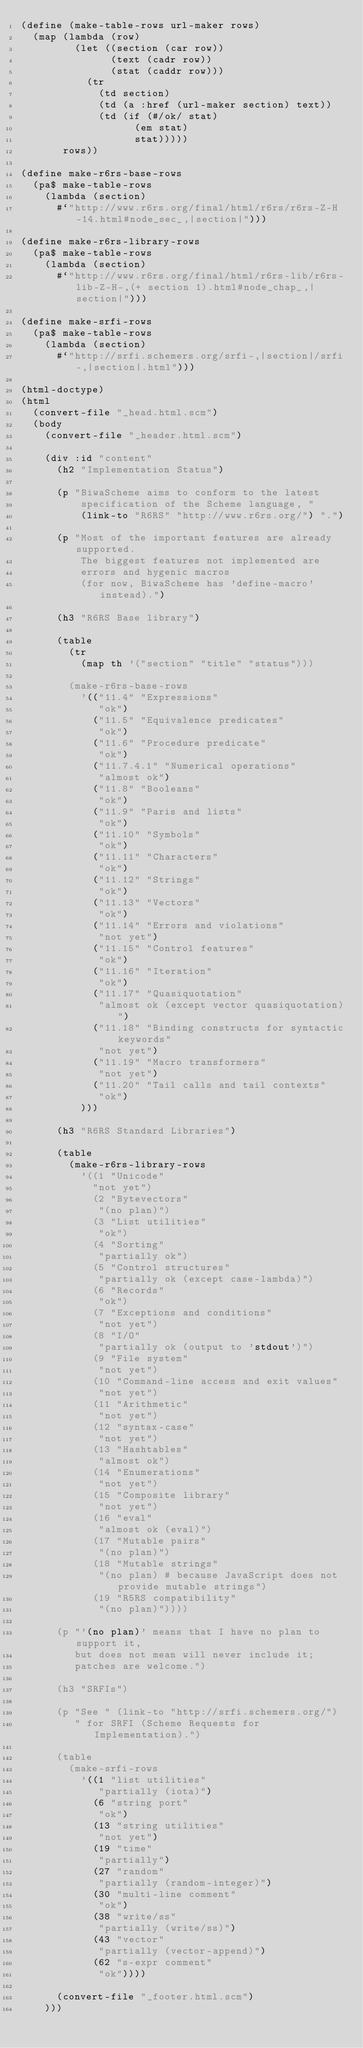Convert code to text. <code><loc_0><loc_0><loc_500><loc_500><_Scheme_>(define (make-table-rows url-maker rows)
  (map (lambda (row)
         (let ((section (car row))
               (text (cadr row))
               (stat (caddr row)))
           (tr
             (td section)
             (td (a :href (url-maker section) text))
             (td (if (#/ok/ stat)
                   (em stat)
                   stat)))))
       rows))

(define make-r6rs-base-rows 
  (pa$ make-table-rows
    (lambda (section)
      #`"http://www.r6rs.org/final/html/r6rs/r6rs-Z-H-14.html#node_sec_,|section|")))

(define make-r6rs-library-rows
  (pa$ make-table-rows
    (lambda (section)
      #`"http://www.r6rs.org/final/html/r6rs-lib/r6rs-lib-Z-H-,(+ section 1).html#node_chap_,|section|")))

(define make-srfi-rows
  (pa$ make-table-rows
    (lambda (section)
      #`"http://srfi.schemers.org/srfi-,|section|/srfi-,|section|.html")))

(html-doctype)
(html
  (convert-file "_head.html.scm")
  (body
    (convert-file "_header.html.scm")

    (div :id "content"
      (h2 "Implementation Status")

      (p "BiwaScheme aims to conform to the latest
          specification of the Scheme language, "
          (link-to "R6RS" "http://www.r6rs.org/") ".")

      (p "Most of the important features are already supported.
          The biggest features not implemented are
          errors and hygenic macros
          (for now, BiwaScheme has 'define-macro' instead).")

      (h3 "R6RS Base library")

      (table
        (tr
          (map th '("section" "title" "status")))

        (make-r6rs-base-rows
          '(("11.4" "Expressions"
             "ok")
            ("11.5" "Equivalence predicates"
             "ok")
            ("11.6" "Procedure predicate"
             "ok")
            ("11.7.4.1" "Numerical operations"
             "almost ok")
            ("11.8" "Booleans"
             "ok")
            ("11.9" "Paris and lists"
             "ok")
            ("11.10" "Symbols"
             "ok")
            ("11.11" "Characters"
             "ok")
            ("11.12" "Strings"
             "ok")
            ("11.13" "Vectors"
             "ok")
            ("11.14" "Errors and violations"
             "not yet")
            ("11.15" "Control features"
             "ok")
            ("11.16" "Iteration"
             "ok")
            ("11.17" "Quasiquotation"
             "almost ok (except vector quasiquotation)")
            ("11.18" "Binding constructs for syntactic keywords"
             "not yet")
            ("11.19" "Macro transformers"
             "not yet")
            ("11.20" "Tail calls and tail contexts"
             "ok")
          )))

      (h3 "R6RS Standard Libraries")
      
      (table
        (make-r6rs-library-rows
          '((1 "Unicode"
            "not yet")
            (2 "Bytevectors"
             "(no plan)")
            (3 "List utilities"
             "ok")
            (4 "Sorting"
             "partially ok")
            (5 "Control structures"
             "partially ok (except case-lambda)")
            (6 "Records"
             "ok")
            (7 "Exceptions and conditions"
             "not yet")
            (8 "I/O"
             "partially ok (output to 'stdout')")
            (9 "File system"
             "not yet")
            (10 "Command-line access and exit values"
             "not yet")
            (11 "Arithmetic"
             "not yet")
            (12 "syntax-case"
             "not yet")
            (13 "Hashtables"
             "almost ok")
            (14 "Enumerations"
             "not yet")
            (15 "Composite library"
             "not yet")
            (16 "eval"
             "almost ok (eval)")
            (17 "Mutable pairs"
             "(no plan)")
            (18 "Mutable strings"
             "(no plan) # because JavaScript does not provide mutable strings")
            (19 "R5RS compatibility"
             "(no plan)"))))

      (p "'(no plan)' means that I have no plan to support it,
         but does not mean will never include it; 
         patches are welcome.")

      (h3 "SRFIs")

      (p "See " (link-to "http://srfi.schemers.org/")
         " for SRFI (Scheme Requests for Implementation).")

      (table
        (make-srfi-rows
          '((1 "list utilities"
             "partially (iota)")
            (6 "string port"
             "ok")
            (13 "string utilities"
             "not yet")
            (19 "time"
             "partially")
            (27 "random"
             "partially (random-integer)")
            (30 "multi-line comment"
             "ok")
            (38 "write/ss"
             "partially (write/ss)")
            (43 "vector"
             "partially (vector-append)")
            (62 "s-expr comment"
             "ok"))))

      (convert-file "_footer.html.scm")
    )))

</code> 